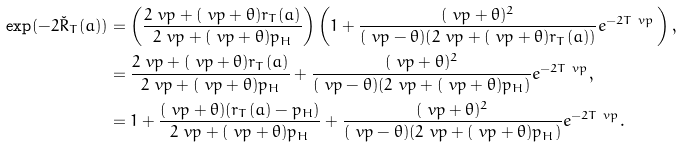<formula> <loc_0><loc_0><loc_500><loc_500>\exp ( - 2 \check { R } _ { T } ( a ) ) & = \left ( \frac { 2 \ v p + ( \ v p + \theta ) r _ { T } ( a ) } { 2 \ v p + ( \ v p + \theta ) p _ { H } } \right ) \left ( 1 + \frac { ( \ v p + \theta ) ^ { 2 } } { ( \ v p - \theta ) ( 2 \ v p + ( \ v p + \theta ) r _ { T } ( a ) ) } e ^ { - 2 T \ v p } \, \right ) , \\ & = \frac { 2 \ v p + ( \ v p + \theta ) r _ { T } ( a ) } { 2 \ v p + ( \ v p + \theta ) p _ { H } } + \frac { ( \ v p + \theta ) ^ { 2 } } { ( \ v p - \theta ) ( 2 \ v p + ( \ v p + \theta ) p _ { H } ) } e ^ { - 2 T \ v p } , \\ & = 1 + \frac { ( \ v p + \theta ) ( r _ { T } ( a ) - p _ { H } ) } { 2 \ v p + ( \ v p + \theta ) p _ { H } } + \frac { ( \ v p + \theta ) ^ { 2 } } { ( \ v p - \theta ) ( 2 \ v p + ( \ v p + \theta ) p _ { H } ) } e ^ { - 2 T \ v p } .</formula> 